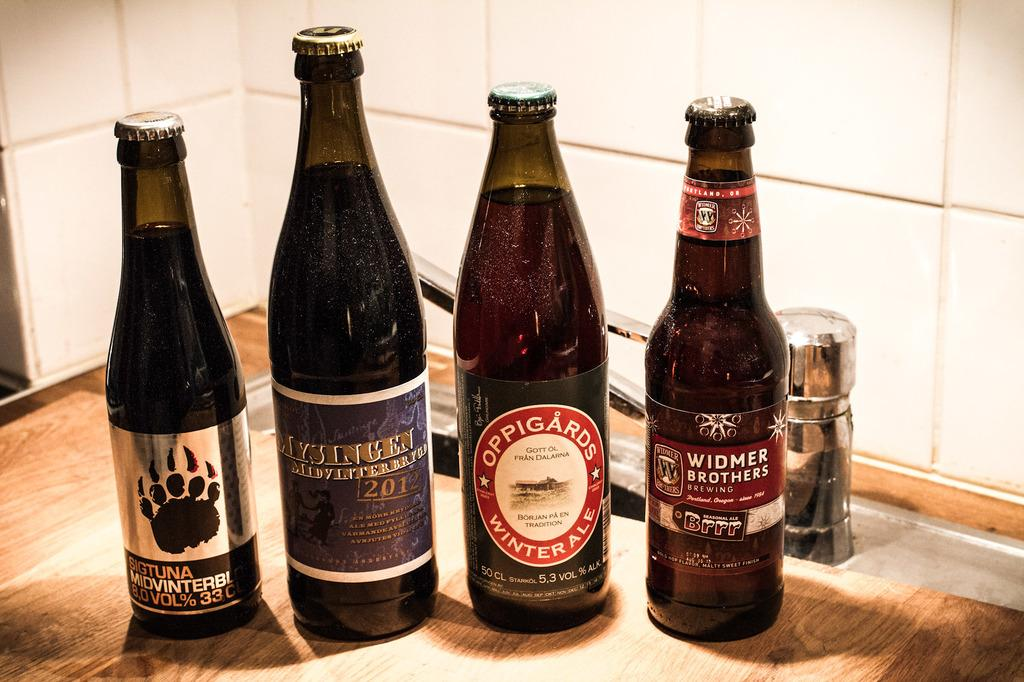Provide a one-sentence caption for the provided image. Four bottles of beer including Oppigards Winter Ale are sitting on a table. 